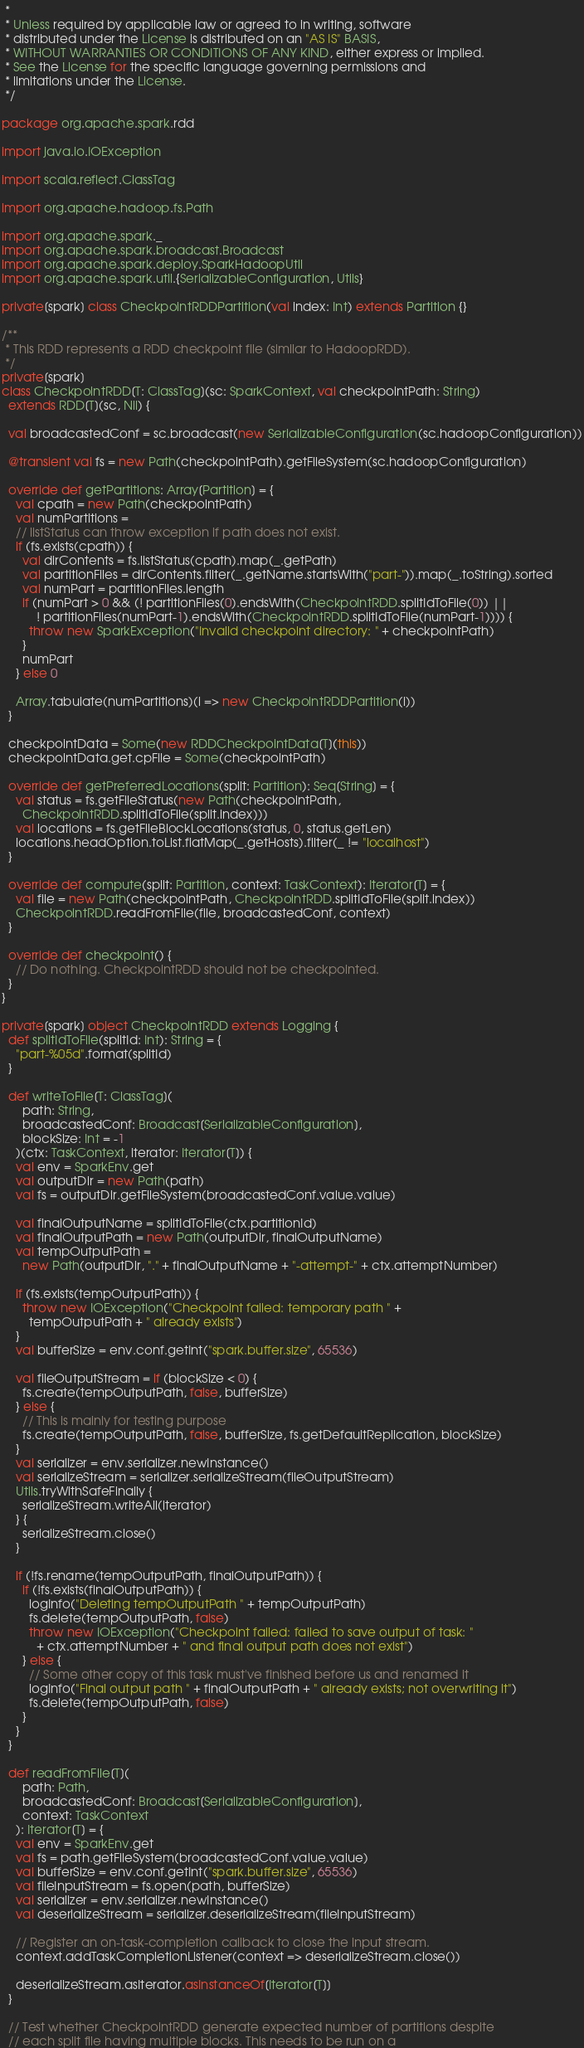<code> <loc_0><loc_0><loc_500><loc_500><_Scala_> *
 * Unless required by applicable law or agreed to in writing, software
 * distributed under the License is distributed on an "AS IS" BASIS,
 * WITHOUT WARRANTIES OR CONDITIONS OF ANY KIND, either express or implied.
 * See the License for the specific language governing permissions and
 * limitations under the License.
 */

package org.apache.spark.rdd

import java.io.IOException

import scala.reflect.ClassTag

import org.apache.hadoop.fs.Path

import org.apache.spark._
import org.apache.spark.broadcast.Broadcast
import org.apache.spark.deploy.SparkHadoopUtil
import org.apache.spark.util.{SerializableConfiguration, Utils}

private[spark] class CheckpointRDDPartition(val index: Int) extends Partition {}

/**
 * This RDD represents a RDD checkpoint file (similar to HadoopRDD).
 */
private[spark]
class CheckpointRDD[T: ClassTag](sc: SparkContext, val checkpointPath: String)
  extends RDD[T](sc, Nil) {

  val broadcastedConf = sc.broadcast(new SerializableConfiguration(sc.hadoopConfiguration))

  @transient val fs = new Path(checkpointPath).getFileSystem(sc.hadoopConfiguration)

  override def getPartitions: Array[Partition] = {
    val cpath = new Path(checkpointPath)
    val numPartitions =
    // listStatus can throw exception if path does not exist.
    if (fs.exists(cpath)) {
      val dirContents = fs.listStatus(cpath).map(_.getPath)
      val partitionFiles = dirContents.filter(_.getName.startsWith("part-")).map(_.toString).sorted
      val numPart = partitionFiles.length
      if (numPart > 0 && (! partitionFiles(0).endsWith(CheckpointRDD.splitIdToFile(0)) ||
          ! partitionFiles(numPart-1).endsWith(CheckpointRDD.splitIdToFile(numPart-1)))) {
        throw new SparkException("Invalid checkpoint directory: " + checkpointPath)
      }
      numPart
    } else 0

    Array.tabulate(numPartitions)(i => new CheckpointRDDPartition(i))
  }

  checkpointData = Some(new RDDCheckpointData[T](this))
  checkpointData.get.cpFile = Some(checkpointPath)

  override def getPreferredLocations(split: Partition): Seq[String] = {
    val status = fs.getFileStatus(new Path(checkpointPath,
      CheckpointRDD.splitIdToFile(split.index)))
    val locations = fs.getFileBlockLocations(status, 0, status.getLen)
    locations.headOption.toList.flatMap(_.getHosts).filter(_ != "localhost")
  }

  override def compute(split: Partition, context: TaskContext): Iterator[T] = {
    val file = new Path(checkpointPath, CheckpointRDD.splitIdToFile(split.index))
    CheckpointRDD.readFromFile(file, broadcastedConf, context)
  }

  override def checkpoint() {
    // Do nothing. CheckpointRDD should not be checkpointed.
  }
}

private[spark] object CheckpointRDD extends Logging {
  def splitIdToFile(splitId: Int): String = {
    "part-%05d".format(splitId)
  }

  def writeToFile[T: ClassTag](
      path: String,
      broadcastedConf: Broadcast[SerializableConfiguration],
      blockSize: Int = -1
    )(ctx: TaskContext, iterator: Iterator[T]) {
    val env = SparkEnv.get
    val outputDir = new Path(path)
    val fs = outputDir.getFileSystem(broadcastedConf.value.value)

    val finalOutputName = splitIdToFile(ctx.partitionId)
    val finalOutputPath = new Path(outputDir, finalOutputName)
    val tempOutputPath =
      new Path(outputDir, "." + finalOutputName + "-attempt-" + ctx.attemptNumber)

    if (fs.exists(tempOutputPath)) {
      throw new IOException("Checkpoint failed: temporary path " +
        tempOutputPath + " already exists")
    }
    val bufferSize = env.conf.getInt("spark.buffer.size", 65536)

    val fileOutputStream = if (blockSize < 0) {
      fs.create(tempOutputPath, false, bufferSize)
    } else {
      // This is mainly for testing purpose
      fs.create(tempOutputPath, false, bufferSize, fs.getDefaultReplication, blockSize)
    }
    val serializer = env.serializer.newInstance()
    val serializeStream = serializer.serializeStream(fileOutputStream)
    Utils.tryWithSafeFinally {
      serializeStream.writeAll(iterator)
    } {
      serializeStream.close()
    }

    if (!fs.rename(tempOutputPath, finalOutputPath)) {
      if (!fs.exists(finalOutputPath)) {
        logInfo("Deleting tempOutputPath " + tempOutputPath)
        fs.delete(tempOutputPath, false)
        throw new IOException("Checkpoint failed: failed to save output of task: "
          + ctx.attemptNumber + " and final output path does not exist")
      } else {
        // Some other copy of this task must've finished before us and renamed it
        logInfo("Final output path " + finalOutputPath + " already exists; not overwriting it")
        fs.delete(tempOutputPath, false)
      }
    }
  }

  def readFromFile[T](
      path: Path,
      broadcastedConf: Broadcast[SerializableConfiguration],
      context: TaskContext
    ): Iterator[T] = {
    val env = SparkEnv.get
    val fs = path.getFileSystem(broadcastedConf.value.value)
    val bufferSize = env.conf.getInt("spark.buffer.size", 65536)
    val fileInputStream = fs.open(path, bufferSize)
    val serializer = env.serializer.newInstance()
    val deserializeStream = serializer.deserializeStream(fileInputStream)

    // Register an on-task-completion callback to close the input stream.
    context.addTaskCompletionListener(context => deserializeStream.close())

    deserializeStream.asIterator.asInstanceOf[Iterator[T]]
  }

  // Test whether CheckpointRDD generate expected number of partitions despite
  // each split file having multiple blocks. This needs to be run on a</code> 